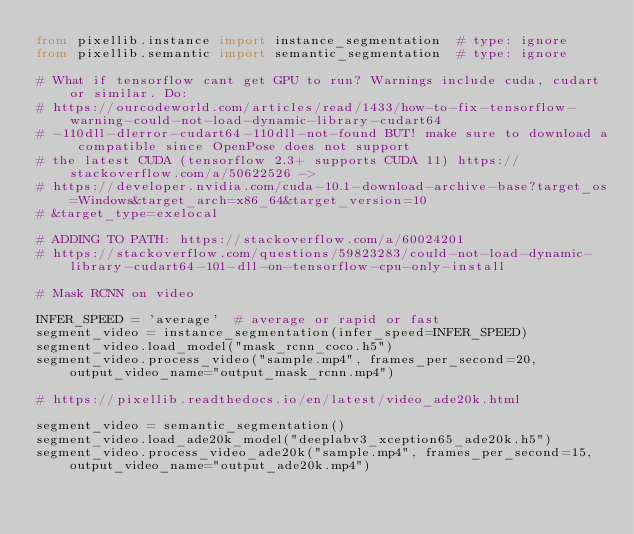<code> <loc_0><loc_0><loc_500><loc_500><_Python_>from pixellib.instance import instance_segmentation  # type: ignore
from pixellib.semantic import semantic_segmentation  # type: ignore

# What if tensorflow cant get GPU to run? Warnings include cuda, cudart or similar. Do:
# https://ourcodeworld.com/articles/read/1433/how-to-fix-tensorflow-warning-could-not-load-dynamic-library-cudart64
# -110dll-dlerror-cudart64-110dll-not-found BUT! make sure to download a compatible since OpenPose does not support
# the latest CUDA (tensorflow 2.3+ supports CUDA 11) https://stackoverflow.com/a/50622526 ->
# https://developer.nvidia.com/cuda-10.1-download-archive-base?target_os=Windows&target_arch=x86_64&target_version=10
# &target_type=exelocal

# ADDING TO PATH: https://stackoverflow.com/a/60024201
# https://stackoverflow.com/questions/59823283/could-not-load-dynamic-library-cudart64-101-dll-on-tensorflow-cpu-only-install

# Mask RCNN on video

INFER_SPEED = 'average'  # average or rapid or fast
segment_video = instance_segmentation(infer_speed=INFER_SPEED)
segment_video.load_model("mask_rcnn_coco.h5")
segment_video.process_video("sample.mp4", frames_per_second=20, output_video_name="output_mask_rcnn.mp4")

# https://pixellib.readthedocs.io/en/latest/video_ade20k.html

segment_video = semantic_segmentation()
segment_video.load_ade20k_model("deeplabv3_xception65_ade20k.h5")
segment_video.process_video_ade20k("sample.mp4", frames_per_second=15, output_video_name="output_ade20k.mp4")
</code> 